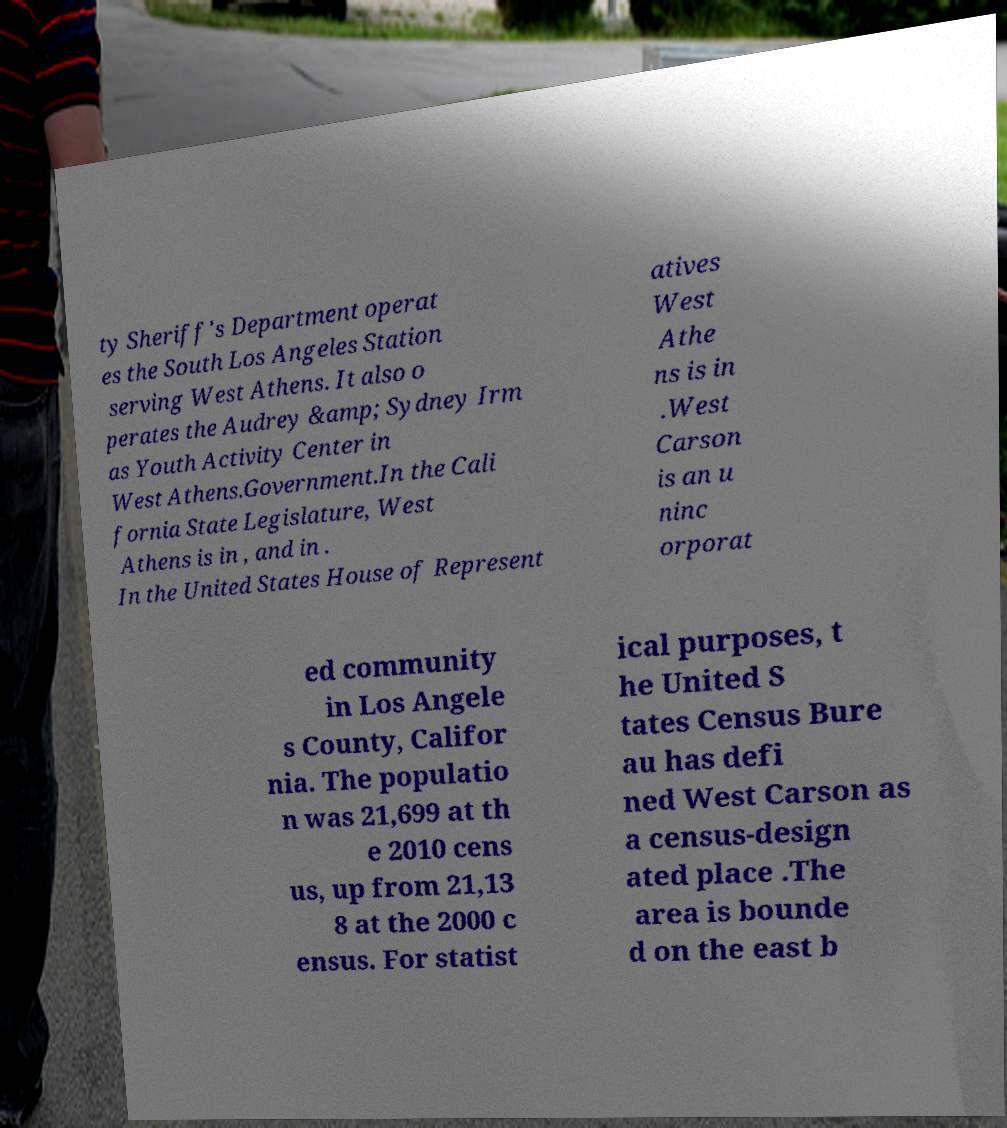I need the written content from this picture converted into text. Can you do that? ty Sheriff's Department operat es the South Los Angeles Station serving West Athens. It also o perates the Audrey &amp; Sydney Irm as Youth Activity Center in West Athens.Government.In the Cali fornia State Legislature, West Athens is in , and in . In the United States House of Represent atives West Athe ns is in .West Carson is an u ninc orporat ed community in Los Angele s County, Califor nia. The populatio n was 21,699 at th e 2010 cens us, up from 21,13 8 at the 2000 c ensus. For statist ical purposes, t he United S tates Census Bure au has defi ned West Carson as a census-design ated place .The area is bounde d on the east b 